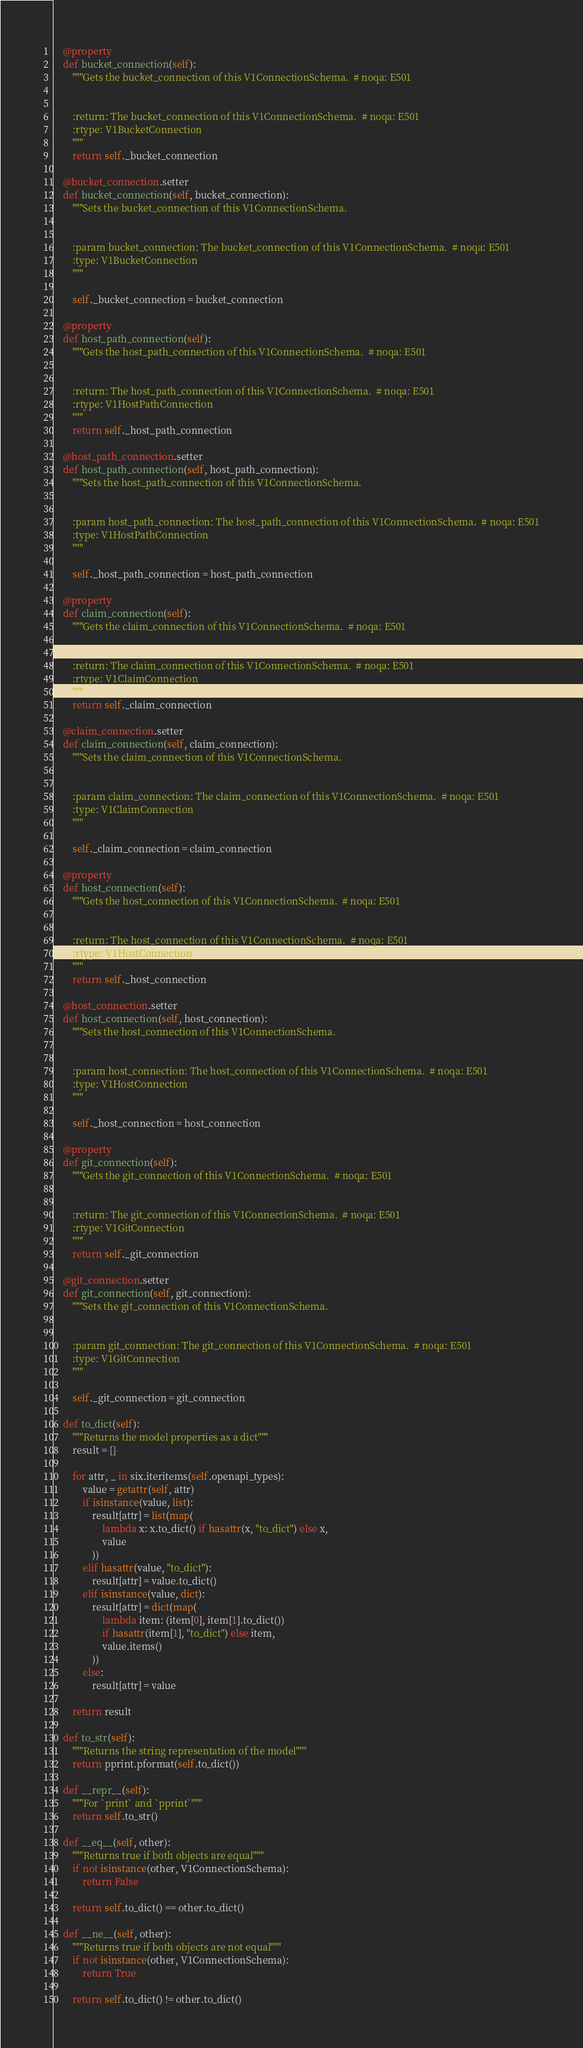Convert code to text. <code><loc_0><loc_0><loc_500><loc_500><_Python_>    @property
    def bucket_connection(self):
        """Gets the bucket_connection of this V1ConnectionSchema.  # noqa: E501


        :return: The bucket_connection of this V1ConnectionSchema.  # noqa: E501
        :rtype: V1BucketConnection
        """
        return self._bucket_connection

    @bucket_connection.setter
    def bucket_connection(self, bucket_connection):
        """Sets the bucket_connection of this V1ConnectionSchema.


        :param bucket_connection: The bucket_connection of this V1ConnectionSchema.  # noqa: E501
        :type: V1BucketConnection
        """

        self._bucket_connection = bucket_connection

    @property
    def host_path_connection(self):
        """Gets the host_path_connection of this V1ConnectionSchema.  # noqa: E501


        :return: The host_path_connection of this V1ConnectionSchema.  # noqa: E501
        :rtype: V1HostPathConnection
        """
        return self._host_path_connection

    @host_path_connection.setter
    def host_path_connection(self, host_path_connection):
        """Sets the host_path_connection of this V1ConnectionSchema.


        :param host_path_connection: The host_path_connection of this V1ConnectionSchema.  # noqa: E501
        :type: V1HostPathConnection
        """

        self._host_path_connection = host_path_connection

    @property
    def claim_connection(self):
        """Gets the claim_connection of this V1ConnectionSchema.  # noqa: E501


        :return: The claim_connection of this V1ConnectionSchema.  # noqa: E501
        :rtype: V1ClaimConnection
        """
        return self._claim_connection

    @claim_connection.setter
    def claim_connection(self, claim_connection):
        """Sets the claim_connection of this V1ConnectionSchema.


        :param claim_connection: The claim_connection of this V1ConnectionSchema.  # noqa: E501
        :type: V1ClaimConnection
        """

        self._claim_connection = claim_connection

    @property
    def host_connection(self):
        """Gets the host_connection of this V1ConnectionSchema.  # noqa: E501


        :return: The host_connection of this V1ConnectionSchema.  # noqa: E501
        :rtype: V1HostConnection
        """
        return self._host_connection

    @host_connection.setter
    def host_connection(self, host_connection):
        """Sets the host_connection of this V1ConnectionSchema.


        :param host_connection: The host_connection of this V1ConnectionSchema.  # noqa: E501
        :type: V1HostConnection
        """

        self._host_connection = host_connection

    @property
    def git_connection(self):
        """Gets the git_connection of this V1ConnectionSchema.  # noqa: E501


        :return: The git_connection of this V1ConnectionSchema.  # noqa: E501
        :rtype: V1GitConnection
        """
        return self._git_connection

    @git_connection.setter
    def git_connection(self, git_connection):
        """Sets the git_connection of this V1ConnectionSchema.


        :param git_connection: The git_connection of this V1ConnectionSchema.  # noqa: E501
        :type: V1GitConnection
        """

        self._git_connection = git_connection

    def to_dict(self):
        """Returns the model properties as a dict"""
        result = {}

        for attr, _ in six.iteritems(self.openapi_types):
            value = getattr(self, attr)
            if isinstance(value, list):
                result[attr] = list(map(
                    lambda x: x.to_dict() if hasattr(x, "to_dict") else x,
                    value
                ))
            elif hasattr(value, "to_dict"):
                result[attr] = value.to_dict()
            elif isinstance(value, dict):
                result[attr] = dict(map(
                    lambda item: (item[0], item[1].to_dict())
                    if hasattr(item[1], "to_dict") else item,
                    value.items()
                ))
            else:
                result[attr] = value

        return result

    def to_str(self):
        """Returns the string representation of the model"""
        return pprint.pformat(self.to_dict())

    def __repr__(self):
        """For `print` and `pprint`"""
        return self.to_str()

    def __eq__(self, other):
        """Returns true if both objects are equal"""
        if not isinstance(other, V1ConnectionSchema):
            return False

        return self.to_dict() == other.to_dict()

    def __ne__(self, other):
        """Returns true if both objects are not equal"""
        if not isinstance(other, V1ConnectionSchema):
            return True

        return self.to_dict() != other.to_dict()
</code> 